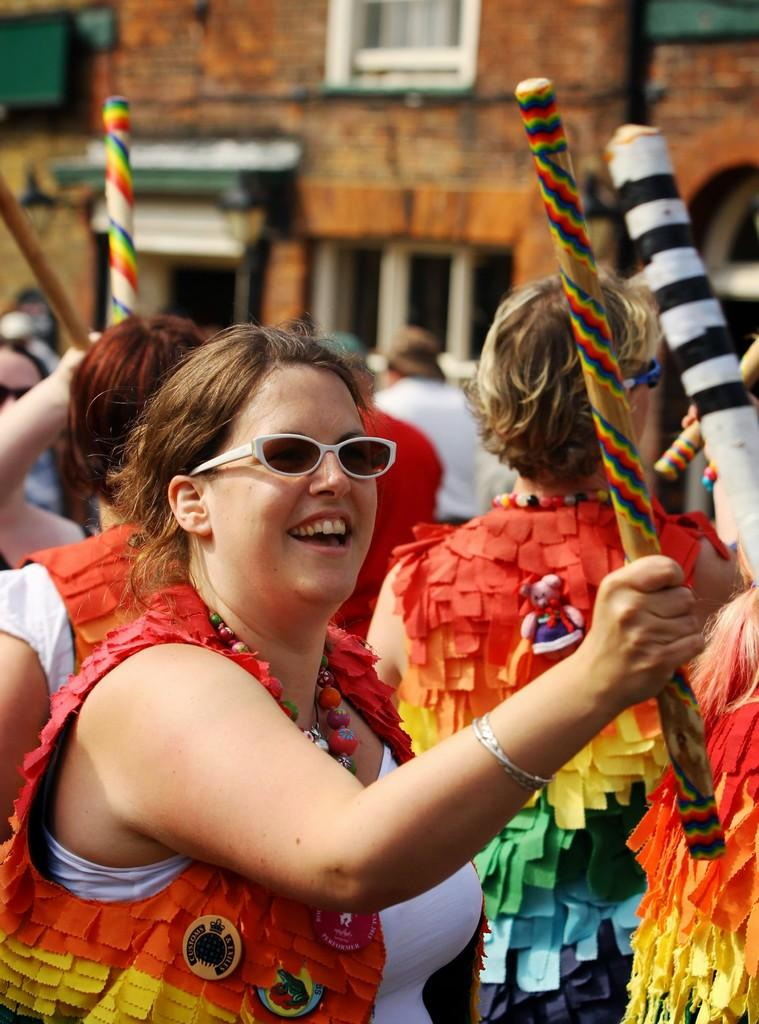What can be seen in the image? There are people standing in the image. What are the people holding? The people are holding sticks. What is visible in the background of the image? There is a building in the background of the image. What type of game are the people playing in the image? There is no indication of a game being played in the image; the people are simply holding sticks. Can you see a robin in the image? There is no robin present in the image. 